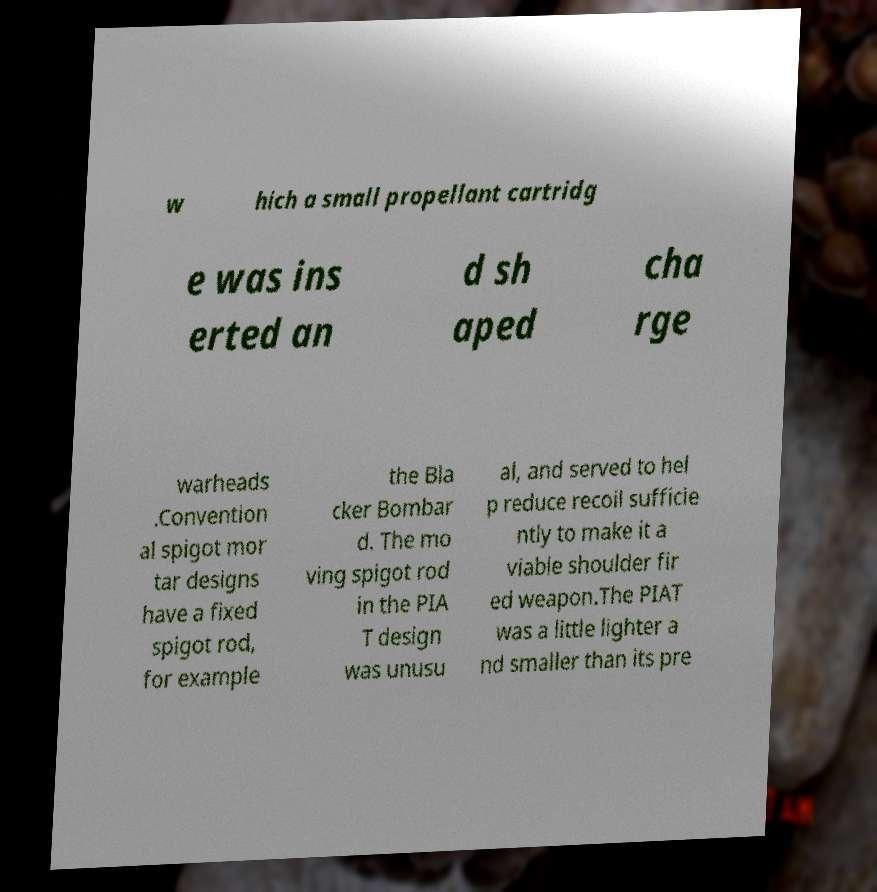Can you read and provide the text displayed in the image?This photo seems to have some interesting text. Can you extract and type it out for me? w hich a small propellant cartridg e was ins erted an d sh aped cha rge warheads .Convention al spigot mor tar designs have a fixed spigot rod, for example the Bla cker Bombar d. The mo ving spigot rod in the PIA T design was unusu al, and served to hel p reduce recoil sufficie ntly to make it a viable shoulder fir ed weapon.The PIAT was a little lighter a nd smaller than its pre 